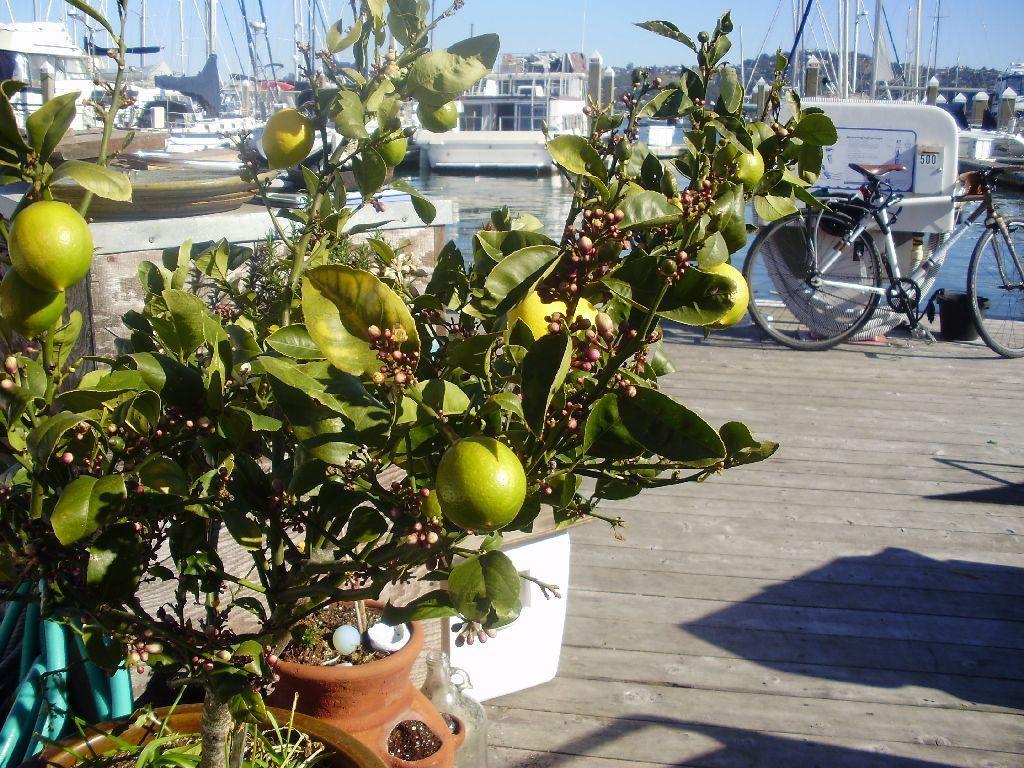Please provide a concise description of this image. In this picture I can see there are plants in the flower pots and there are few fruits to the plants and there is a wooden floor and a bicycle is parked in the backdrop and there are few boats sailing on the water and there is a mountain in the backdrop and the sky is clear. 